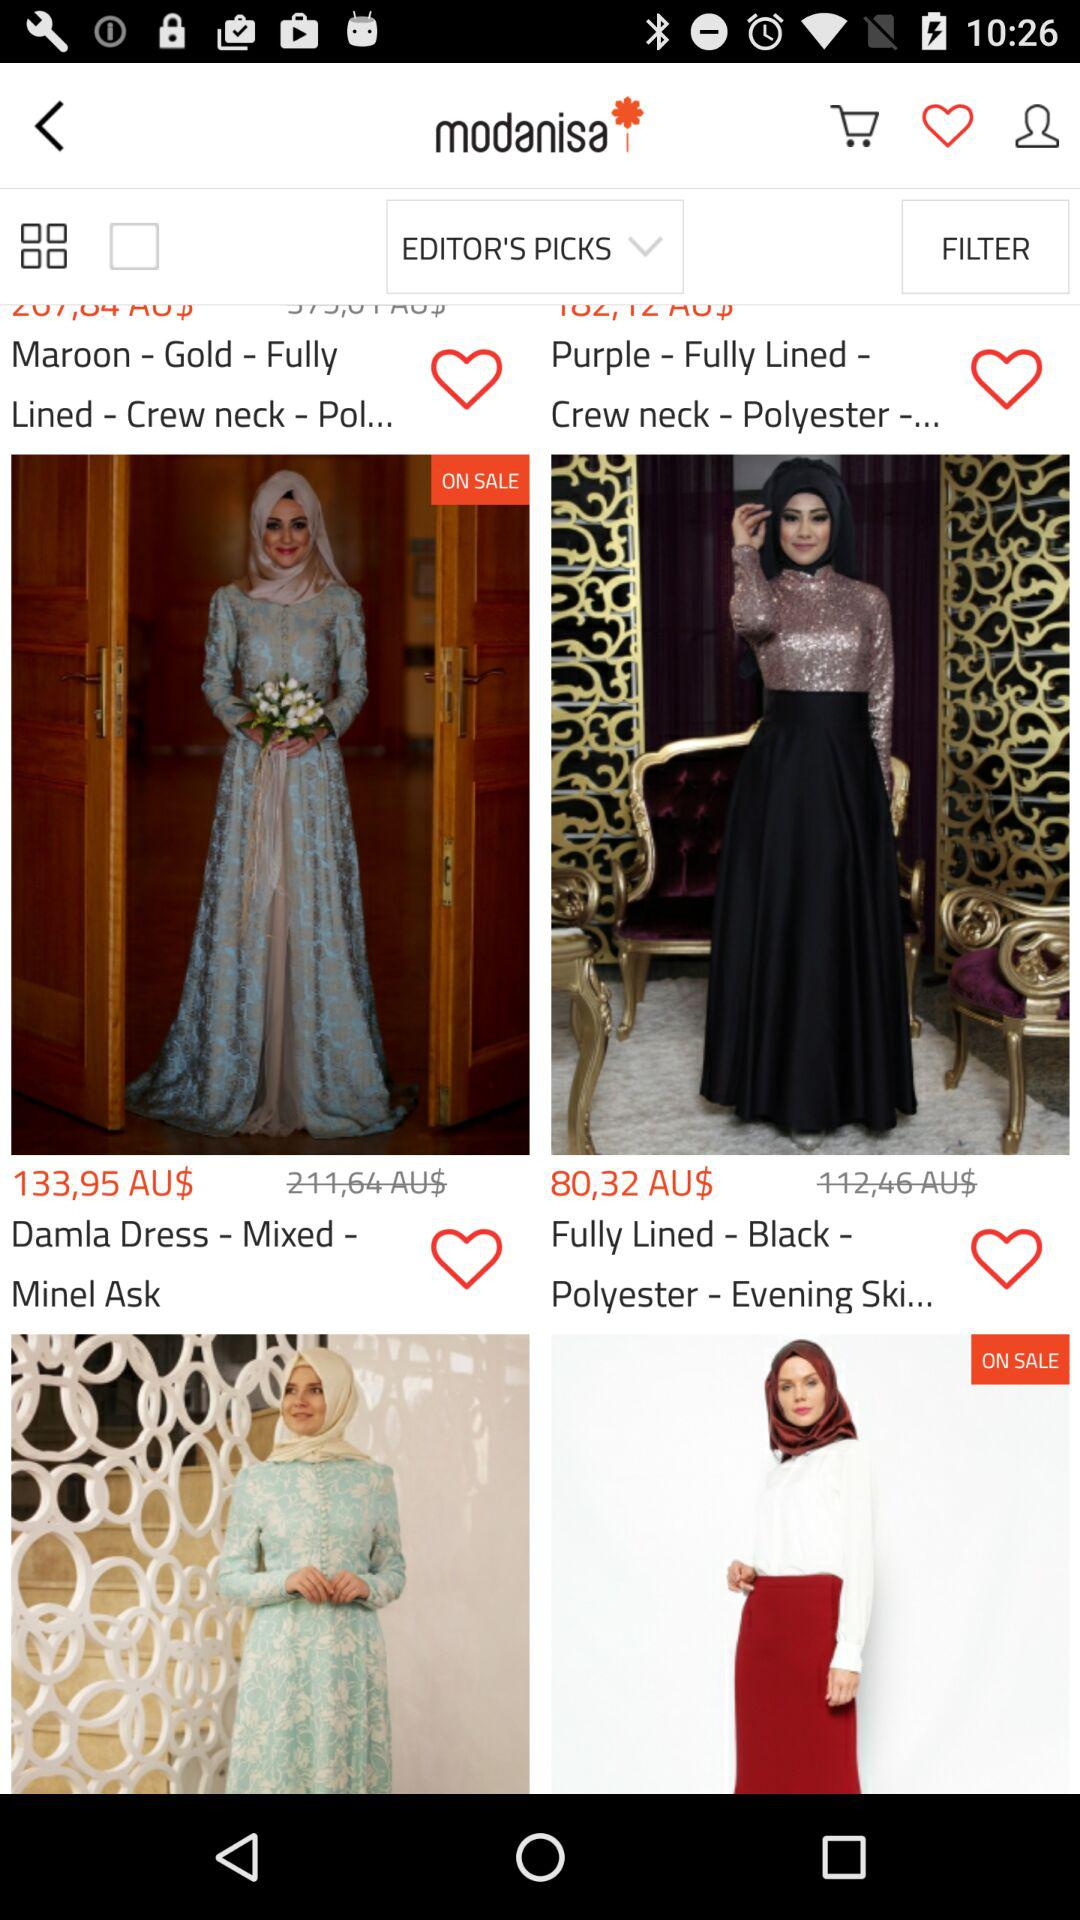What is the brand name? The brand name is "modanisa". 